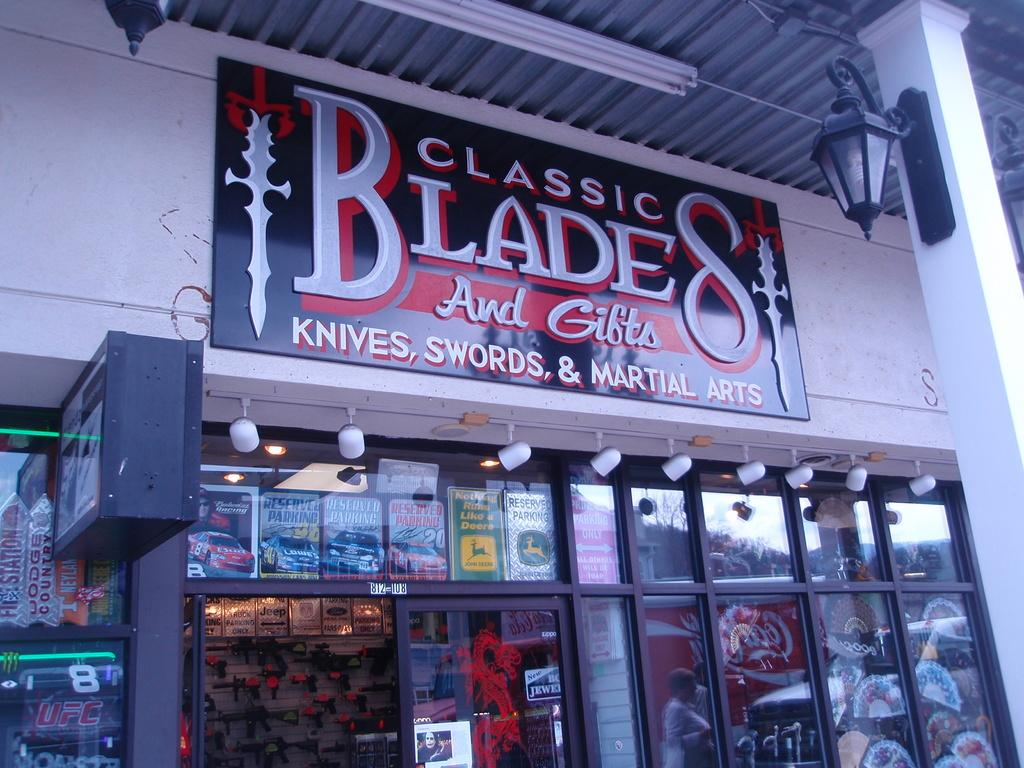Provide a one-sentence caption for the provided image. Sharp implements of all kinds can be purchased at a store named Classic Blades. 